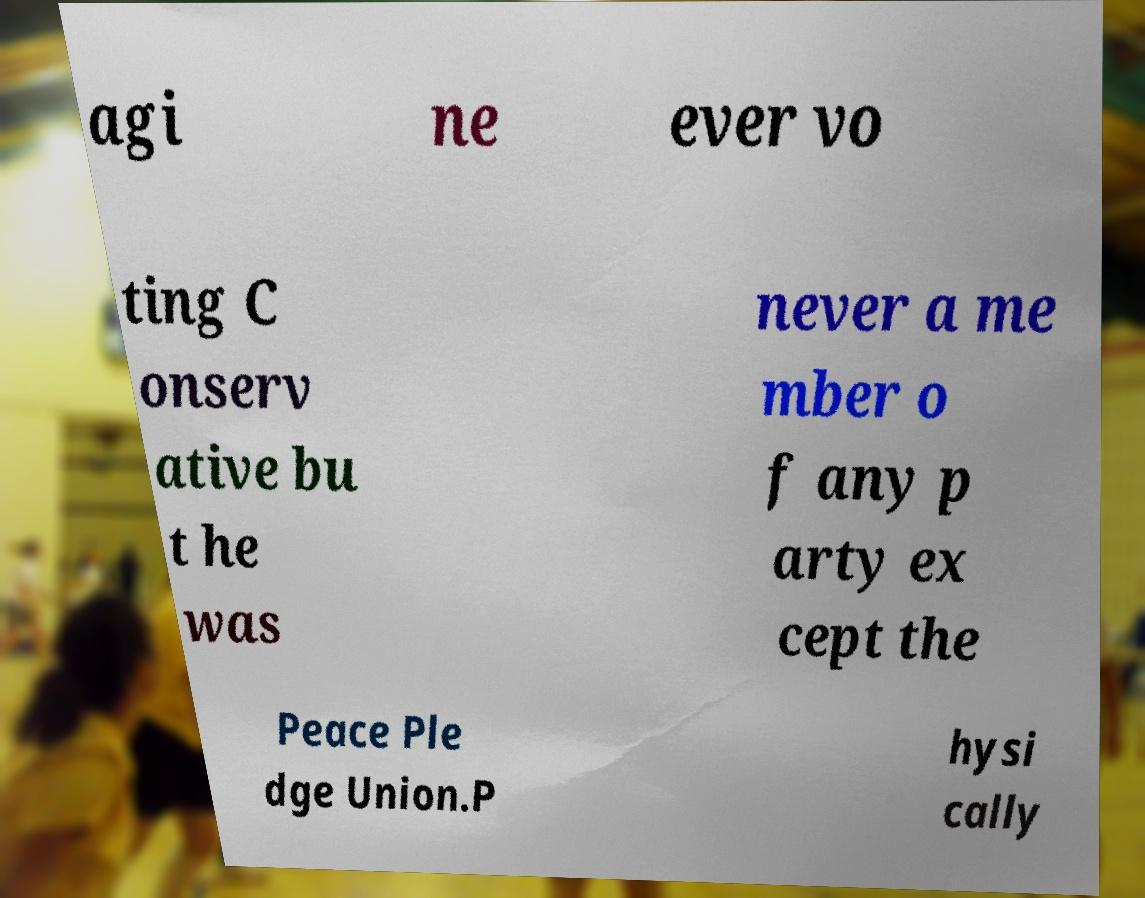I need the written content from this picture converted into text. Can you do that? agi ne ever vo ting C onserv ative bu t he was never a me mber o f any p arty ex cept the Peace Ple dge Union.P hysi cally 